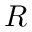Convert formula to latex. <formula><loc_0><loc_0><loc_500><loc_500>R</formula> 